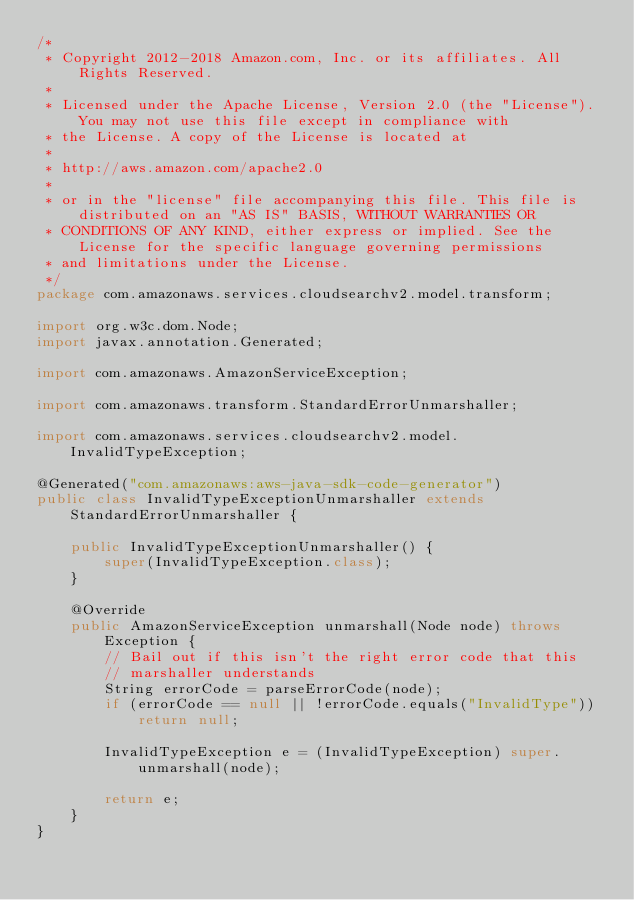Convert code to text. <code><loc_0><loc_0><loc_500><loc_500><_Java_>/*
 * Copyright 2012-2018 Amazon.com, Inc. or its affiliates. All Rights Reserved.
 * 
 * Licensed under the Apache License, Version 2.0 (the "License"). You may not use this file except in compliance with
 * the License. A copy of the License is located at
 * 
 * http://aws.amazon.com/apache2.0
 * 
 * or in the "license" file accompanying this file. This file is distributed on an "AS IS" BASIS, WITHOUT WARRANTIES OR
 * CONDITIONS OF ANY KIND, either express or implied. See the License for the specific language governing permissions
 * and limitations under the License.
 */
package com.amazonaws.services.cloudsearchv2.model.transform;

import org.w3c.dom.Node;
import javax.annotation.Generated;

import com.amazonaws.AmazonServiceException;

import com.amazonaws.transform.StandardErrorUnmarshaller;

import com.amazonaws.services.cloudsearchv2.model.InvalidTypeException;

@Generated("com.amazonaws:aws-java-sdk-code-generator")
public class InvalidTypeExceptionUnmarshaller extends StandardErrorUnmarshaller {

    public InvalidTypeExceptionUnmarshaller() {
        super(InvalidTypeException.class);
    }

    @Override
    public AmazonServiceException unmarshall(Node node) throws Exception {
        // Bail out if this isn't the right error code that this
        // marshaller understands
        String errorCode = parseErrorCode(node);
        if (errorCode == null || !errorCode.equals("InvalidType"))
            return null;

        InvalidTypeException e = (InvalidTypeException) super.unmarshall(node);

        return e;
    }
}
</code> 